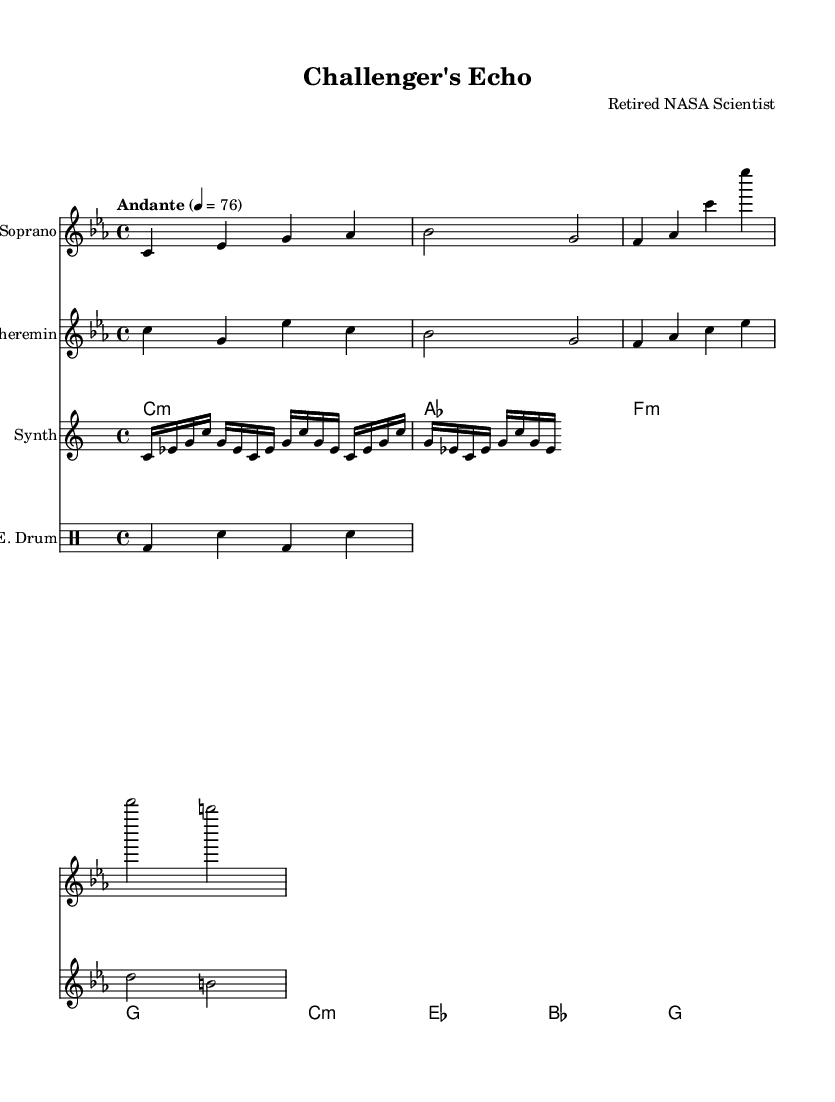What is the key signature of this music? The key signature is C minor, which is indicated by three flats in the key signature on the staff.
Answer: C minor What is the time signature of the piece? The time signature is 4/4, which is shown at the beginning of the score and indicates that there are four beats in each measure.
Answer: 4/4 What is the tempo marking given? The tempo marking states "Andante" with a metronome marking of 76 beats per minute, indicating a moderately slow tempo.
Answer: Andante How many measures are present in the soprano voice part? The soprano voice part contains four measures, as can be counted from the notes and bar lines provided in the staff.
Answer: Four measures What type of instrument is used for the synthesizer section? The synthesizer is indicated as an instrument in the score, specifically noted in the instrumentation section. It is designed to create electronic sounds, which enhances the futuristic atmosphere of the piece.
Answer: Synthesizer What theme do the lyrics of the chorus represent? The lyrics of the chorus express a memorial theme, reflecting on the legacy and spirit of the Challenger as a symbol of eternal flight, which ties back to the operatic context of space exploration.
Answer: Legacy theme 